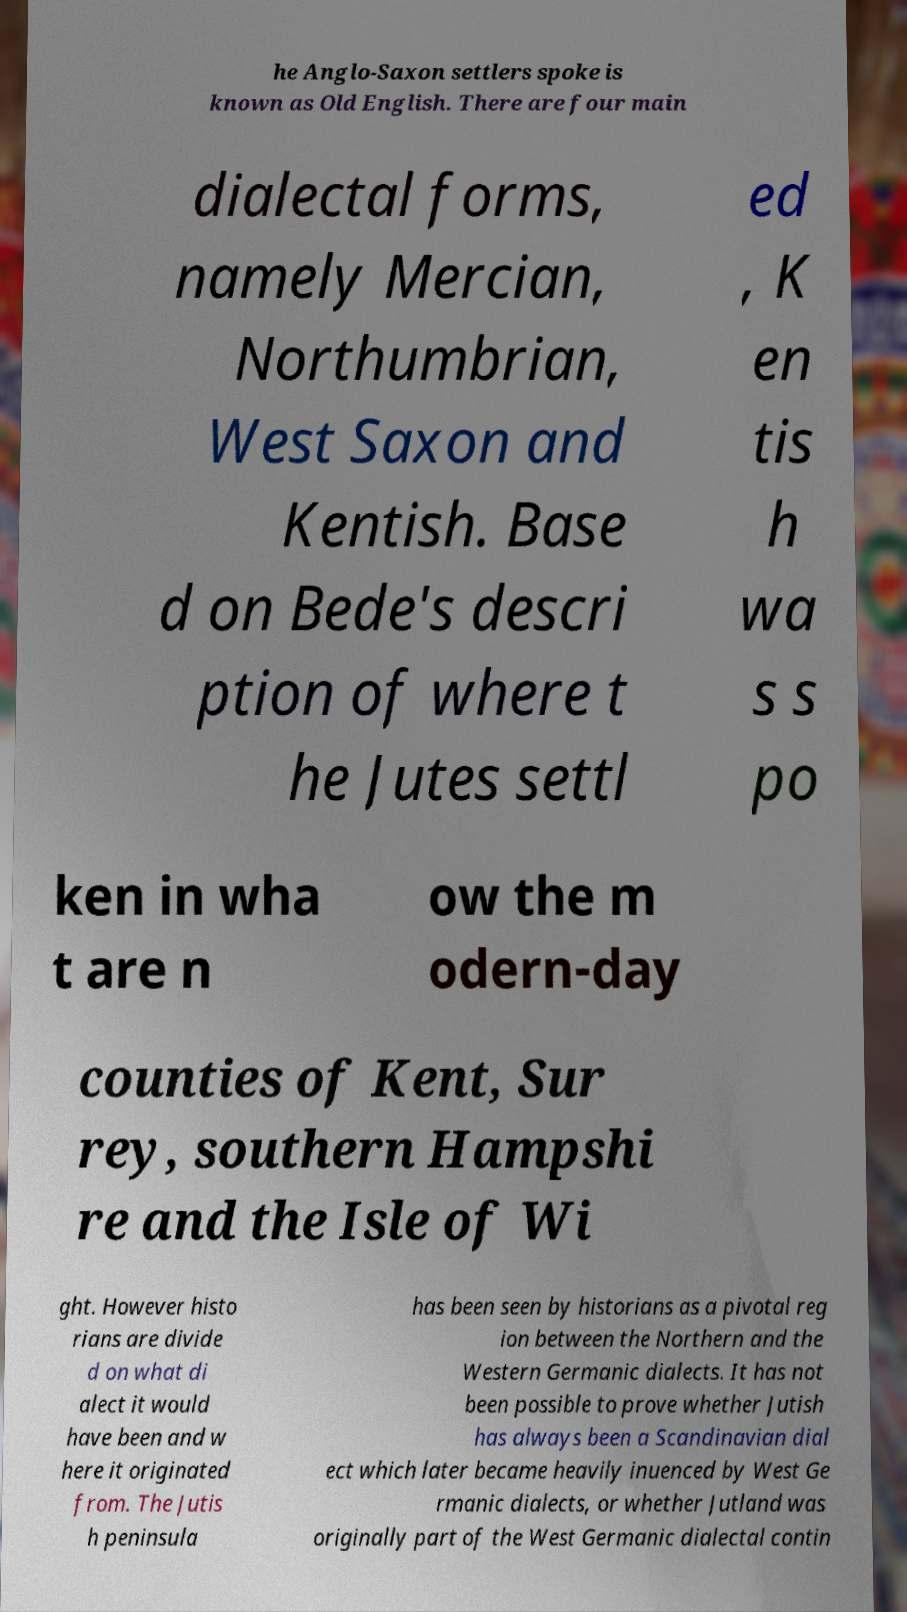Can you read and provide the text displayed in the image?This photo seems to have some interesting text. Can you extract and type it out for me? he Anglo-Saxon settlers spoke is known as Old English. There are four main dialectal forms, namely Mercian, Northumbrian, West Saxon and Kentish. Base d on Bede's descri ption of where t he Jutes settl ed , K en tis h wa s s po ken in wha t are n ow the m odern-day counties of Kent, Sur rey, southern Hampshi re and the Isle of Wi ght. However histo rians are divide d on what di alect it would have been and w here it originated from. The Jutis h peninsula has been seen by historians as a pivotal reg ion between the Northern and the Western Germanic dialects. It has not been possible to prove whether Jutish has always been a Scandinavian dial ect which later became heavily inuenced by West Ge rmanic dialects, or whether Jutland was originally part of the West Germanic dialectal contin 